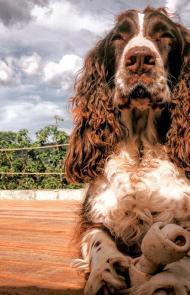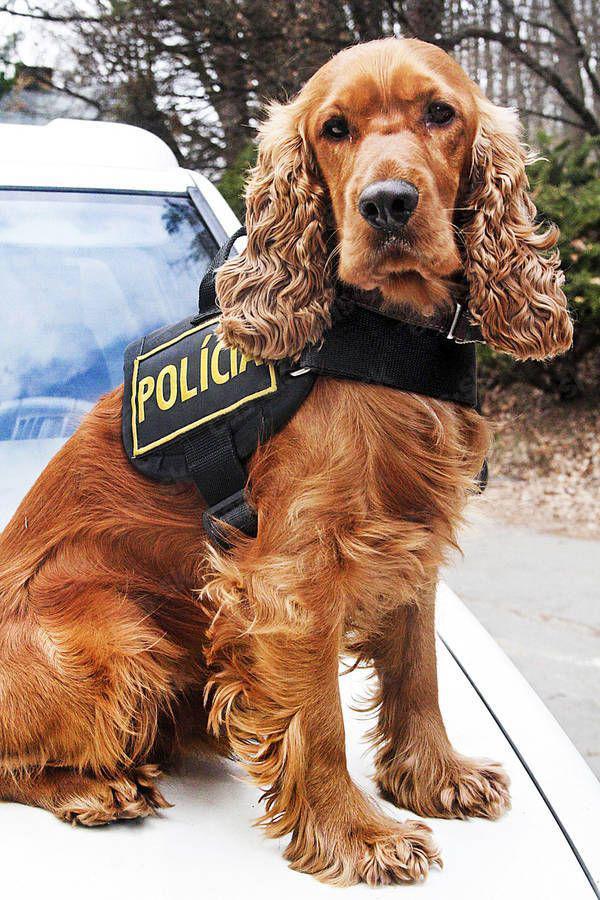The first image is the image on the left, the second image is the image on the right. For the images displayed, is the sentence "The dogs in each of the images are situated outside." factually correct? Answer yes or no. Yes. The first image is the image on the left, the second image is the image on the right. For the images displayed, is the sentence "One image shows an upright spaniel with bedraggled wet fur, especially on its ears, and the other image shows one spaniel with a coat of dry fur in one color." factually correct? Answer yes or no. No. 